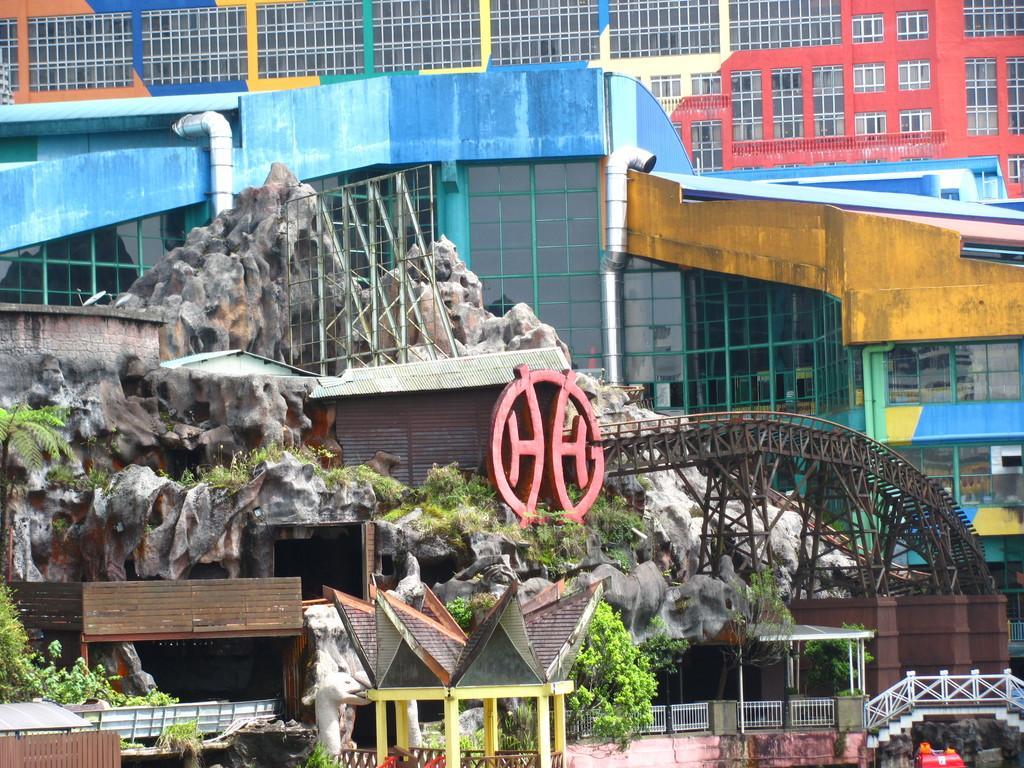Could you give a brief overview of what you see in this image? In the picture we can see a building with many windows with glasses and near to it, we can see some rock kind of construction on it, we can see some bridges, plants and huts and some railings. 